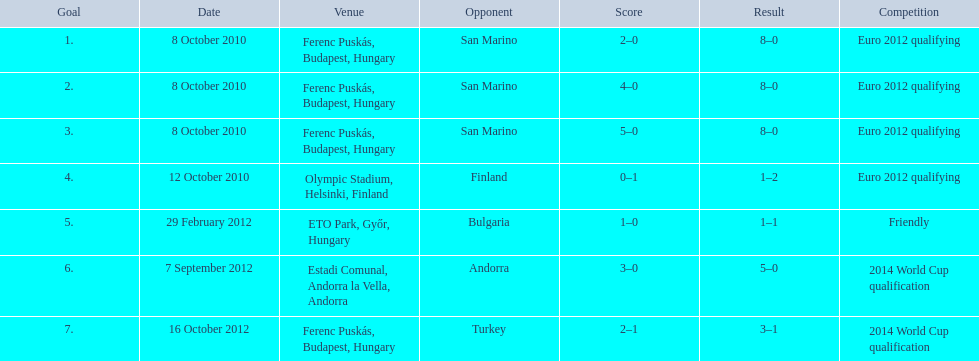What is the cumulative number of international goals ádám szalai has scored? 7. 